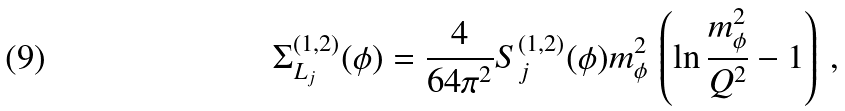Convert formula to latex. <formula><loc_0><loc_0><loc_500><loc_500>\Sigma _ { L _ { j } } ^ { ( 1 , 2 ) } ( \phi ) = { \frac { 4 } { 6 4 \pi ^ { 2 } } } S _ { j } ^ { ( 1 , 2 ) } ( \phi ) m _ { \phi } ^ { 2 } \, \left ( \ln { \frac { m _ { \phi } ^ { 2 } } { Q ^ { 2 } } } - 1 \right ) \, ,</formula> 